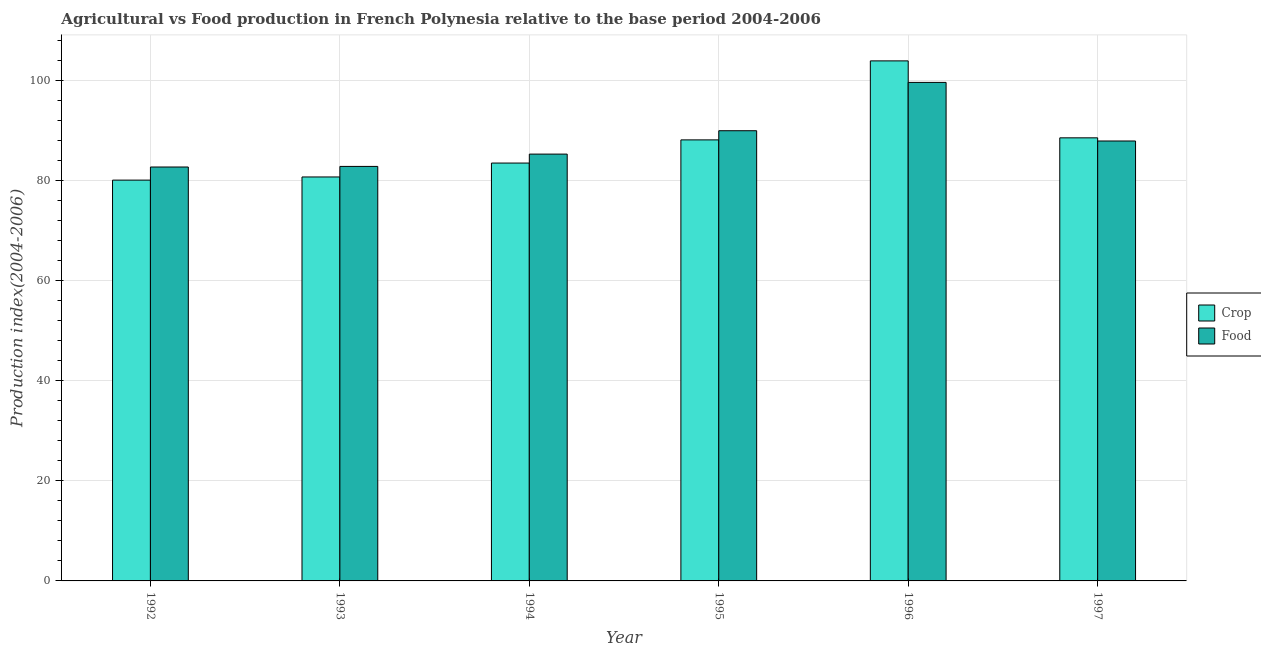How many groups of bars are there?
Give a very brief answer. 6. Are the number of bars per tick equal to the number of legend labels?
Provide a succinct answer. Yes. Are the number of bars on each tick of the X-axis equal?
Your answer should be compact. Yes. How many bars are there on the 3rd tick from the right?
Provide a short and direct response. 2. In how many cases, is the number of bars for a given year not equal to the number of legend labels?
Keep it short and to the point. 0. What is the crop production index in 1996?
Provide a short and direct response. 103.93. Across all years, what is the maximum crop production index?
Offer a terse response. 103.93. Across all years, what is the minimum crop production index?
Make the answer very short. 80.1. What is the total crop production index in the graph?
Your answer should be very brief. 524.96. What is the difference between the food production index in 1994 and that in 1995?
Offer a terse response. -4.67. What is the difference between the crop production index in 1995 and the food production index in 1994?
Your answer should be compact. 4.63. What is the average crop production index per year?
Offer a very short reply. 87.49. In the year 1996, what is the difference between the food production index and crop production index?
Provide a succinct answer. 0. What is the ratio of the crop production index in 1995 to that in 1997?
Make the answer very short. 1. Is the difference between the crop production index in 1995 and 1997 greater than the difference between the food production index in 1995 and 1997?
Keep it short and to the point. No. What is the difference between the highest and the second highest food production index?
Ensure brevity in your answer.  9.66. What is the difference between the highest and the lowest food production index?
Provide a succinct answer. 16.91. In how many years, is the food production index greater than the average food production index taken over all years?
Keep it short and to the point. 2. Is the sum of the crop production index in 1992 and 1993 greater than the maximum food production index across all years?
Make the answer very short. Yes. What does the 2nd bar from the left in 1992 represents?
Make the answer very short. Food. What does the 1st bar from the right in 1995 represents?
Keep it short and to the point. Food. How many bars are there?
Your answer should be very brief. 12. Are all the bars in the graph horizontal?
Provide a short and direct response. No. Does the graph contain any zero values?
Give a very brief answer. No. How many legend labels are there?
Provide a short and direct response. 2. What is the title of the graph?
Give a very brief answer. Agricultural vs Food production in French Polynesia relative to the base period 2004-2006. What is the label or title of the Y-axis?
Provide a succinct answer. Production index(2004-2006). What is the Production index(2004-2006) of Crop in 1992?
Offer a very short reply. 80.1. What is the Production index(2004-2006) in Food in 1992?
Provide a short and direct response. 82.72. What is the Production index(2004-2006) of Crop in 1993?
Give a very brief answer. 80.73. What is the Production index(2004-2006) in Food in 1993?
Offer a terse response. 82.84. What is the Production index(2004-2006) in Crop in 1994?
Provide a short and direct response. 83.51. What is the Production index(2004-2006) in Food in 1994?
Keep it short and to the point. 85.3. What is the Production index(2004-2006) in Crop in 1995?
Give a very brief answer. 88.14. What is the Production index(2004-2006) of Food in 1995?
Ensure brevity in your answer.  89.97. What is the Production index(2004-2006) in Crop in 1996?
Your response must be concise. 103.93. What is the Production index(2004-2006) in Food in 1996?
Keep it short and to the point. 99.63. What is the Production index(2004-2006) in Crop in 1997?
Ensure brevity in your answer.  88.55. What is the Production index(2004-2006) of Food in 1997?
Offer a very short reply. 87.92. Across all years, what is the maximum Production index(2004-2006) of Crop?
Your answer should be compact. 103.93. Across all years, what is the maximum Production index(2004-2006) in Food?
Make the answer very short. 99.63. Across all years, what is the minimum Production index(2004-2006) in Crop?
Ensure brevity in your answer.  80.1. Across all years, what is the minimum Production index(2004-2006) in Food?
Give a very brief answer. 82.72. What is the total Production index(2004-2006) of Crop in the graph?
Your response must be concise. 524.96. What is the total Production index(2004-2006) in Food in the graph?
Your response must be concise. 528.38. What is the difference between the Production index(2004-2006) in Crop in 1992 and that in 1993?
Your answer should be compact. -0.63. What is the difference between the Production index(2004-2006) of Food in 1992 and that in 1993?
Keep it short and to the point. -0.12. What is the difference between the Production index(2004-2006) of Crop in 1992 and that in 1994?
Give a very brief answer. -3.41. What is the difference between the Production index(2004-2006) of Food in 1992 and that in 1994?
Provide a succinct answer. -2.58. What is the difference between the Production index(2004-2006) in Crop in 1992 and that in 1995?
Provide a short and direct response. -8.04. What is the difference between the Production index(2004-2006) of Food in 1992 and that in 1995?
Offer a terse response. -7.25. What is the difference between the Production index(2004-2006) in Crop in 1992 and that in 1996?
Your response must be concise. -23.83. What is the difference between the Production index(2004-2006) in Food in 1992 and that in 1996?
Your answer should be very brief. -16.91. What is the difference between the Production index(2004-2006) in Crop in 1992 and that in 1997?
Give a very brief answer. -8.45. What is the difference between the Production index(2004-2006) of Crop in 1993 and that in 1994?
Provide a succinct answer. -2.78. What is the difference between the Production index(2004-2006) of Food in 1993 and that in 1994?
Offer a very short reply. -2.46. What is the difference between the Production index(2004-2006) in Crop in 1993 and that in 1995?
Ensure brevity in your answer.  -7.41. What is the difference between the Production index(2004-2006) of Food in 1993 and that in 1995?
Your response must be concise. -7.13. What is the difference between the Production index(2004-2006) in Crop in 1993 and that in 1996?
Offer a very short reply. -23.2. What is the difference between the Production index(2004-2006) of Food in 1993 and that in 1996?
Make the answer very short. -16.79. What is the difference between the Production index(2004-2006) of Crop in 1993 and that in 1997?
Your answer should be compact. -7.82. What is the difference between the Production index(2004-2006) in Food in 1993 and that in 1997?
Provide a short and direct response. -5.08. What is the difference between the Production index(2004-2006) of Crop in 1994 and that in 1995?
Your response must be concise. -4.63. What is the difference between the Production index(2004-2006) of Food in 1994 and that in 1995?
Offer a very short reply. -4.67. What is the difference between the Production index(2004-2006) of Crop in 1994 and that in 1996?
Keep it short and to the point. -20.42. What is the difference between the Production index(2004-2006) in Food in 1994 and that in 1996?
Give a very brief answer. -14.33. What is the difference between the Production index(2004-2006) of Crop in 1994 and that in 1997?
Offer a terse response. -5.04. What is the difference between the Production index(2004-2006) of Food in 1994 and that in 1997?
Keep it short and to the point. -2.62. What is the difference between the Production index(2004-2006) of Crop in 1995 and that in 1996?
Your answer should be compact. -15.79. What is the difference between the Production index(2004-2006) of Food in 1995 and that in 1996?
Ensure brevity in your answer.  -9.66. What is the difference between the Production index(2004-2006) of Crop in 1995 and that in 1997?
Ensure brevity in your answer.  -0.41. What is the difference between the Production index(2004-2006) in Food in 1995 and that in 1997?
Ensure brevity in your answer.  2.05. What is the difference between the Production index(2004-2006) of Crop in 1996 and that in 1997?
Provide a short and direct response. 15.38. What is the difference between the Production index(2004-2006) in Food in 1996 and that in 1997?
Keep it short and to the point. 11.71. What is the difference between the Production index(2004-2006) in Crop in 1992 and the Production index(2004-2006) in Food in 1993?
Offer a terse response. -2.74. What is the difference between the Production index(2004-2006) of Crop in 1992 and the Production index(2004-2006) of Food in 1994?
Your response must be concise. -5.2. What is the difference between the Production index(2004-2006) of Crop in 1992 and the Production index(2004-2006) of Food in 1995?
Offer a terse response. -9.87. What is the difference between the Production index(2004-2006) of Crop in 1992 and the Production index(2004-2006) of Food in 1996?
Your response must be concise. -19.53. What is the difference between the Production index(2004-2006) in Crop in 1992 and the Production index(2004-2006) in Food in 1997?
Keep it short and to the point. -7.82. What is the difference between the Production index(2004-2006) of Crop in 1993 and the Production index(2004-2006) of Food in 1994?
Provide a short and direct response. -4.57. What is the difference between the Production index(2004-2006) in Crop in 1993 and the Production index(2004-2006) in Food in 1995?
Your response must be concise. -9.24. What is the difference between the Production index(2004-2006) in Crop in 1993 and the Production index(2004-2006) in Food in 1996?
Provide a short and direct response. -18.9. What is the difference between the Production index(2004-2006) in Crop in 1993 and the Production index(2004-2006) in Food in 1997?
Provide a short and direct response. -7.19. What is the difference between the Production index(2004-2006) in Crop in 1994 and the Production index(2004-2006) in Food in 1995?
Keep it short and to the point. -6.46. What is the difference between the Production index(2004-2006) of Crop in 1994 and the Production index(2004-2006) of Food in 1996?
Keep it short and to the point. -16.12. What is the difference between the Production index(2004-2006) of Crop in 1994 and the Production index(2004-2006) of Food in 1997?
Give a very brief answer. -4.41. What is the difference between the Production index(2004-2006) in Crop in 1995 and the Production index(2004-2006) in Food in 1996?
Your answer should be very brief. -11.49. What is the difference between the Production index(2004-2006) in Crop in 1995 and the Production index(2004-2006) in Food in 1997?
Keep it short and to the point. 0.22. What is the difference between the Production index(2004-2006) in Crop in 1996 and the Production index(2004-2006) in Food in 1997?
Give a very brief answer. 16.01. What is the average Production index(2004-2006) of Crop per year?
Your answer should be compact. 87.49. What is the average Production index(2004-2006) of Food per year?
Give a very brief answer. 88.06. In the year 1992, what is the difference between the Production index(2004-2006) in Crop and Production index(2004-2006) in Food?
Provide a succinct answer. -2.62. In the year 1993, what is the difference between the Production index(2004-2006) of Crop and Production index(2004-2006) of Food?
Offer a terse response. -2.11. In the year 1994, what is the difference between the Production index(2004-2006) of Crop and Production index(2004-2006) of Food?
Keep it short and to the point. -1.79. In the year 1995, what is the difference between the Production index(2004-2006) of Crop and Production index(2004-2006) of Food?
Keep it short and to the point. -1.83. In the year 1997, what is the difference between the Production index(2004-2006) of Crop and Production index(2004-2006) of Food?
Offer a terse response. 0.63. What is the ratio of the Production index(2004-2006) in Crop in 1992 to that in 1994?
Offer a terse response. 0.96. What is the ratio of the Production index(2004-2006) of Food in 1992 to that in 1994?
Provide a succinct answer. 0.97. What is the ratio of the Production index(2004-2006) in Crop in 1992 to that in 1995?
Provide a succinct answer. 0.91. What is the ratio of the Production index(2004-2006) of Food in 1992 to that in 1995?
Provide a short and direct response. 0.92. What is the ratio of the Production index(2004-2006) in Crop in 1992 to that in 1996?
Ensure brevity in your answer.  0.77. What is the ratio of the Production index(2004-2006) in Food in 1992 to that in 1996?
Keep it short and to the point. 0.83. What is the ratio of the Production index(2004-2006) in Crop in 1992 to that in 1997?
Your answer should be very brief. 0.9. What is the ratio of the Production index(2004-2006) in Food in 1992 to that in 1997?
Ensure brevity in your answer.  0.94. What is the ratio of the Production index(2004-2006) of Crop in 1993 to that in 1994?
Your answer should be very brief. 0.97. What is the ratio of the Production index(2004-2006) of Food in 1993 to that in 1994?
Ensure brevity in your answer.  0.97. What is the ratio of the Production index(2004-2006) in Crop in 1993 to that in 1995?
Offer a very short reply. 0.92. What is the ratio of the Production index(2004-2006) in Food in 1993 to that in 1995?
Provide a short and direct response. 0.92. What is the ratio of the Production index(2004-2006) in Crop in 1993 to that in 1996?
Your response must be concise. 0.78. What is the ratio of the Production index(2004-2006) of Food in 1993 to that in 1996?
Your answer should be compact. 0.83. What is the ratio of the Production index(2004-2006) in Crop in 1993 to that in 1997?
Give a very brief answer. 0.91. What is the ratio of the Production index(2004-2006) of Food in 1993 to that in 1997?
Your answer should be compact. 0.94. What is the ratio of the Production index(2004-2006) of Crop in 1994 to that in 1995?
Ensure brevity in your answer.  0.95. What is the ratio of the Production index(2004-2006) of Food in 1994 to that in 1995?
Offer a terse response. 0.95. What is the ratio of the Production index(2004-2006) in Crop in 1994 to that in 1996?
Your answer should be compact. 0.8. What is the ratio of the Production index(2004-2006) of Food in 1994 to that in 1996?
Offer a terse response. 0.86. What is the ratio of the Production index(2004-2006) of Crop in 1994 to that in 1997?
Your answer should be compact. 0.94. What is the ratio of the Production index(2004-2006) of Food in 1994 to that in 1997?
Offer a very short reply. 0.97. What is the ratio of the Production index(2004-2006) in Crop in 1995 to that in 1996?
Keep it short and to the point. 0.85. What is the ratio of the Production index(2004-2006) of Food in 1995 to that in 1996?
Provide a succinct answer. 0.9. What is the ratio of the Production index(2004-2006) of Crop in 1995 to that in 1997?
Provide a succinct answer. 1. What is the ratio of the Production index(2004-2006) of Food in 1995 to that in 1997?
Your answer should be compact. 1.02. What is the ratio of the Production index(2004-2006) in Crop in 1996 to that in 1997?
Your answer should be compact. 1.17. What is the ratio of the Production index(2004-2006) in Food in 1996 to that in 1997?
Offer a terse response. 1.13. What is the difference between the highest and the second highest Production index(2004-2006) of Crop?
Your response must be concise. 15.38. What is the difference between the highest and the second highest Production index(2004-2006) of Food?
Provide a succinct answer. 9.66. What is the difference between the highest and the lowest Production index(2004-2006) of Crop?
Your response must be concise. 23.83. What is the difference between the highest and the lowest Production index(2004-2006) of Food?
Offer a terse response. 16.91. 